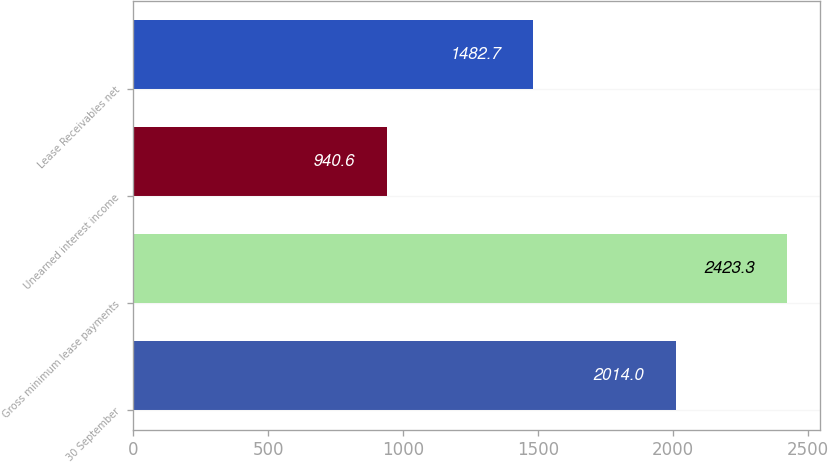Convert chart to OTSL. <chart><loc_0><loc_0><loc_500><loc_500><bar_chart><fcel>30 September<fcel>Gross minimum lease payments<fcel>Unearned interest income<fcel>Lease Receivables net<nl><fcel>2014<fcel>2423.3<fcel>940.6<fcel>1482.7<nl></chart> 